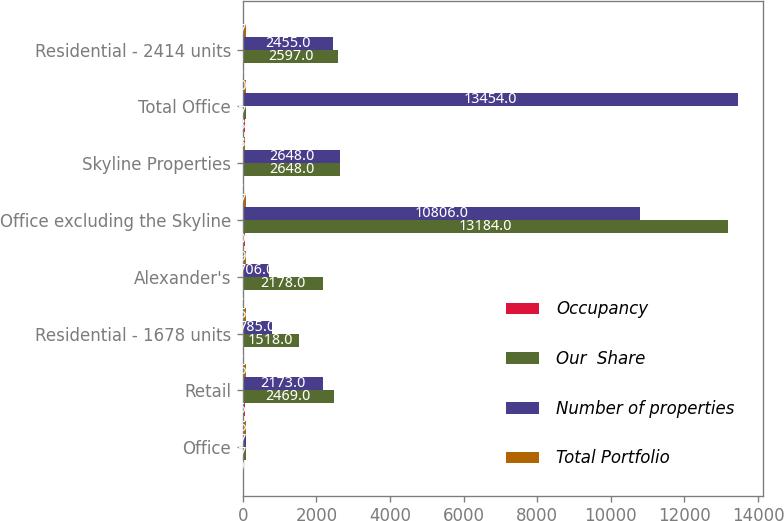Convert chart. <chart><loc_0><loc_0><loc_500><loc_500><stacked_bar_chart><ecel><fcel>Office<fcel>Retail<fcel>Residential - 1678 units<fcel>Alexander's<fcel>Office excluding the Skyline<fcel>Skyline Properties<fcel>Total Office<fcel>Residential - 2414 units<nl><fcel>Occupancy<fcel>30<fcel>56<fcel>9<fcel>6<fcel>50<fcel>8<fcel>58<fcel>7<nl><fcel>Our  Share<fcel>97.4<fcel>2469<fcel>1518<fcel>2178<fcel>13184<fcel>2648<fcel>97.4<fcel>2597<nl><fcel>Number of properties<fcel>97.4<fcel>2173<fcel>785<fcel>706<fcel>10806<fcel>2648<fcel>13454<fcel>2455<nl><fcel>Total Portfolio<fcel>96.9<fcel>96.5<fcel>95.2<fcel>99.7<fcel>87.4<fcel>53.5<fcel>80.7<fcel>97.4<nl></chart> 